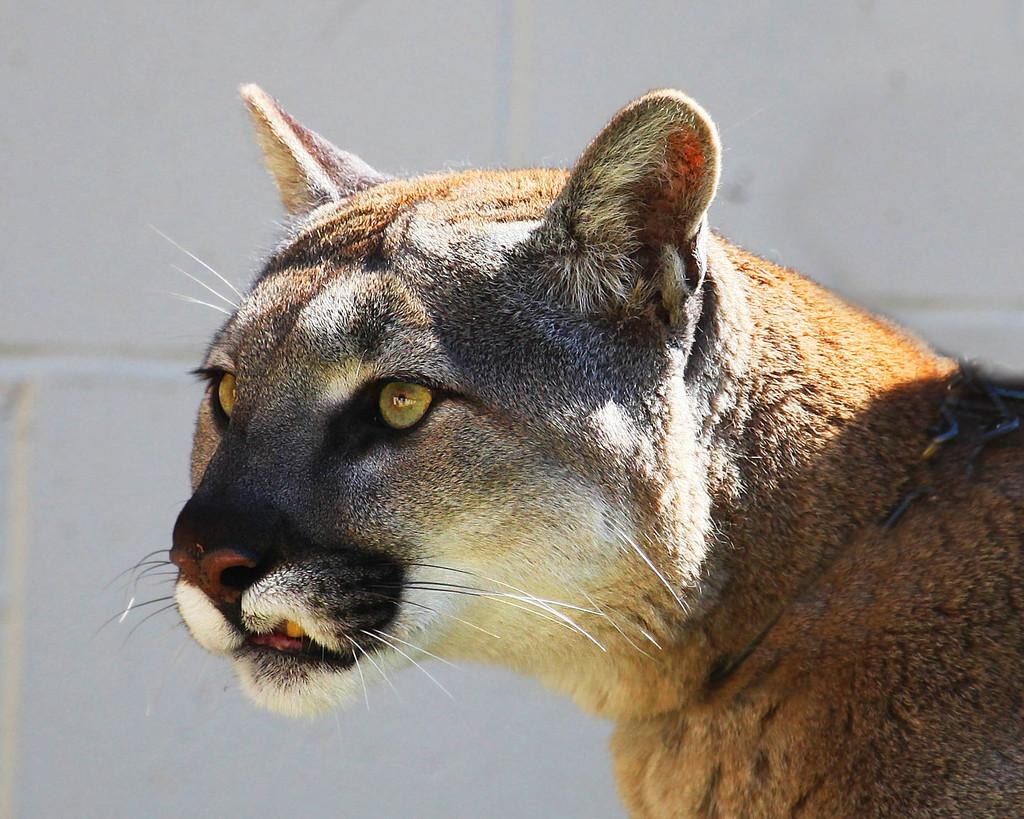What type of animal is in the image? The facts do not specify the type of animal, but it has white, brown, and black colors. Can you describe the color pattern of the animal? The animal has white, brown, and black colors. What is the color of the background in the image? The background of the image is white. What type of coal is being used to comb the animal's fur in the image? There is no coal or comb present in the image, and the animal's fur is not being combed. 